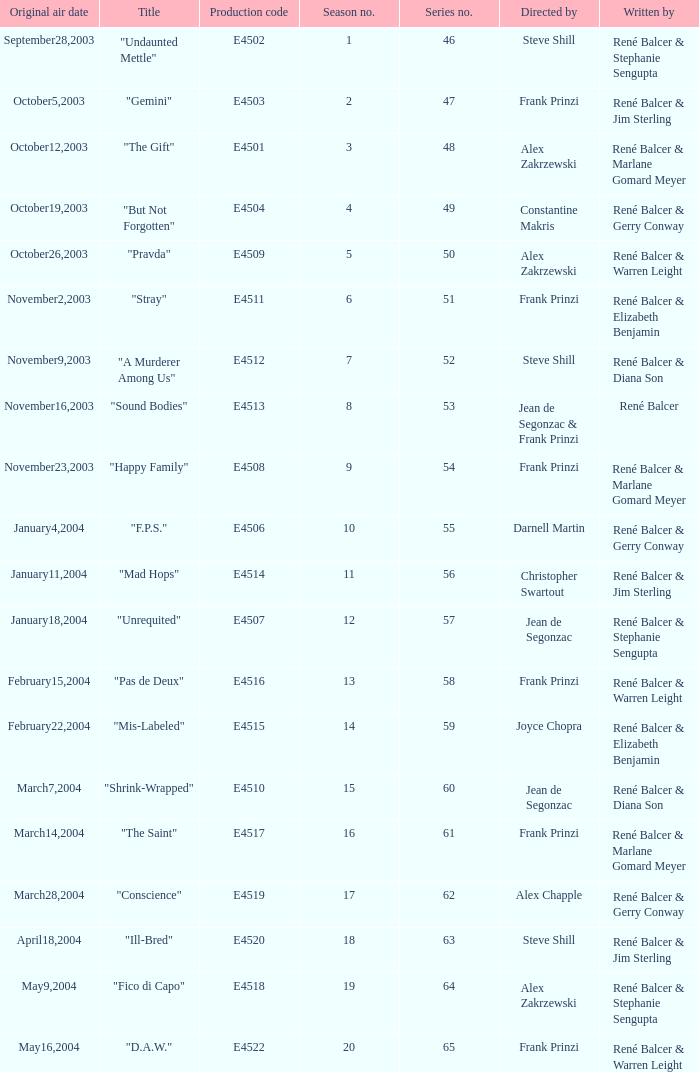What date did "d.a.w." Originally air? May16,2004. 